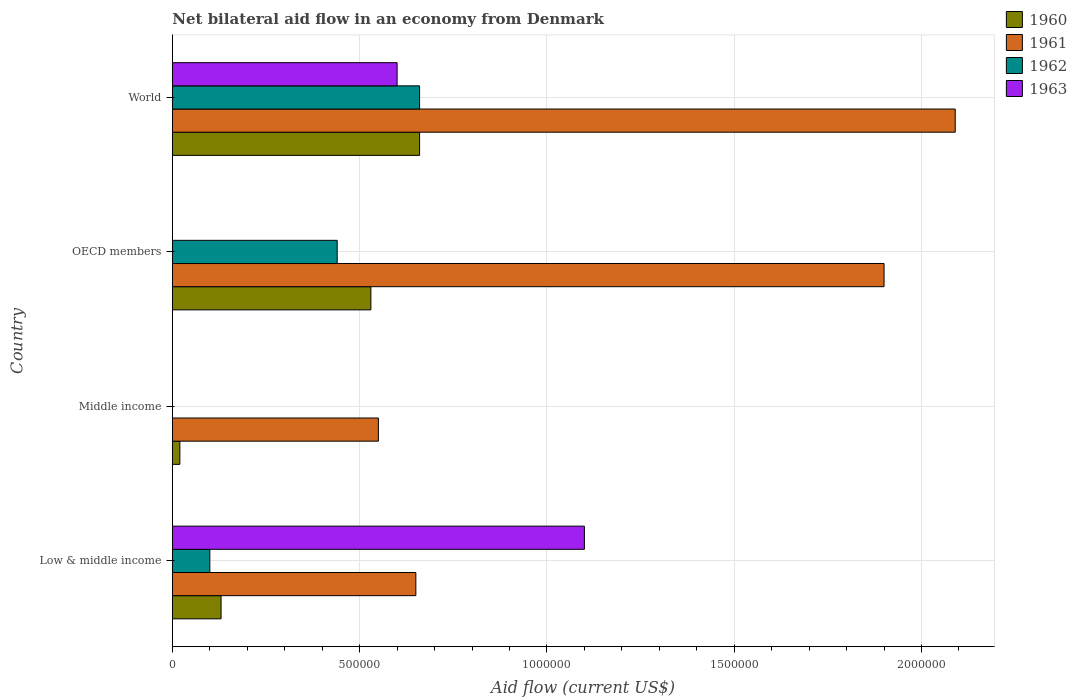How many different coloured bars are there?
Your answer should be very brief. 4. What is the label of the 3rd group of bars from the top?
Provide a short and direct response. Middle income. Across all countries, what is the maximum net bilateral aid flow in 1961?
Provide a short and direct response. 2.09e+06. What is the total net bilateral aid flow in 1960 in the graph?
Your answer should be compact. 1.34e+06. What is the difference between the net bilateral aid flow in 1961 in Middle income and that in OECD members?
Offer a terse response. -1.35e+06. What is the difference between the net bilateral aid flow in 1963 in OECD members and the net bilateral aid flow in 1961 in Low & middle income?
Provide a succinct answer. -6.50e+05. What is the average net bilateral aid flow in 1962 per country?
Your answer should be compact. 3.00e+05. What is the difference between the net bilateral aid flow in 1961 and net bilateral aid flow in 1960 in Low & middle income?
Make the answer very short. 5.20e+05. In how many countries, is the net bilateral aid flow in 1962 greater than 2000000 US$?
Your response must be concise. 0. What is the ratio of the net bilateral aid flow in 1961 in OECD members to that in World?
Make the answer very short. 0.91. Is the net bilateral aid flow in 1961 in Middle income less than that in OECD members?
Give a very brief answer. Yes. Is the difference between the net bilateral aid flow in 1961 in Middle income and World greater than the difference between the net bilateral aid flow in 1960 in Middle income and World?
Offer a very short reply. No. What is the difference between the highest and the second highest net bilateral aid flow in 1961?
Your answer should be very brief. 1.90e+05. What is the difference between the highest and the lowest net bilateral aid flow in 1963?
Give a very brief answer. 1.10e+06. Is the sum of the net bilateral aid flow in 1961 in Middle income and World greater than the maximum net bilateral aid flow in 1963 across all countries?
Offer a very short reply. Yes. Is it the case that in every country, the sum of the net bilateral aid flow in 1962 and net bilateral aid flow in 1960 is greater than the sum of net bilateral aid flow in 1963 and net bilateral aid flow in 1961?
Keep it short and to the point. No. Are all the bars in the graph horizontal?
Keep it short and to the point. Yes. Does the graph contain grids?
Your answer should be compact. Yes. Where does the legend appear in the graph?
Ensure brevity in your answer.  Top right. How are the legend labels stacked?
Offer a very short reply. Vertical. What is the title of the graph?
Your answer should be compact. Net bilateral aid flow in an economy from Denmark. What is the Aid flow (current US$) in 1961 in Low & middle income?
Your answer should be very brief. 6.50e+05. What is the Aid flow (current US$) of 1962 in Low & middle income?
Keep it short and to the point. 1.00e+05. What is the Aid flow (current US$) in 1963 in Low & middle income?
Give a very brief answer. 1.10e+06. What is the Aid flow (current US$) in 1960 in Middle income?
Your answer should be compact. 2.00e+04. What is the Aid flow (current US$) in 1961 in Middle income?
Your answer should be very brief. 5.50e+05. What is the Aid flow (current US$) of 1962 in Middle income?
Ensure brevity in your answer.  0. What is the Aid flow (current US$) in 1960 in OECD members?
Offer a terse response. 5.30e+05. What is the Aid flow (current US$) of 1961 in OECD members?
Offer a terse response. 1.90e+06. What is the Aid flow (current US$) in 1960 in World?
Provide a short and direct response. 6.60e+05. What is the Aid flow (current US$) in 1961 in World?
Keep it short and to the point. 2.09e+06. What is the Aid flow (current US$) in 1962 in World?
Your answer should be very brief. 6.60e+05. What is the Aid flow (current US$) of 1963 in World?
Your answer should be compact. 6.00e+05. Across all countries, what is the maximum Aid flow (current US$) of 1960?
Offer a very short reply. 6.60e+05. Across all countries, what is the maximum Aid flow (current US$) of 1961?
Offer a very short reply. 2.09e+06. Across all countries, what is the maximum Aid flow (current US$) of 1962?
Your answer should be compact. 6.60e+05. Across all countries, what is the maximum Aid flow (current US$) in 1963?
Offer a very short reply. 1.10e+06. Across all countries, what is the minimum Aid flow (current US$) in 1960?
Offer a very short reply. 2.00e+04. Across all countries, what is the minimum Aid flow (current US$) in 1962?
Keep it short and to the point. 0. Across all countries, what is the minimum Aid flow (current US$) in 1963?
Provide a succinct answer. 0. What is the total Aid flow (current US$) of 1960 in the graph?
Make the answer very short. 1.34e+06. What is the total Aid flow (current US$) of 1961 in the graph?
Your response must be concise. 5.19e+06. What is the total Aid flow (current US$) of 1962 in the graph?
Keep it short and to the point. 1.20e+06. What is the total Aid flow (current US$) of 1963 in the graph?
Provide a succinct answer. 1.70e+06. What is the difference between the Aid flow (current US$) of 1960 in Low & middle income and that in Middle income?
Keep it short and to the point. 1.10e+05. What is the difference between the Aid flow (current US$) of 1961 in Low & middle income and that in Middle income?
Keep it short and to the point. 1.00e+05. What is the difference between the Aid flow (current US$) of 1960 in Low & middle income and that in OECD members?
Keep it short and to the point. -4.00e+05. What is the difference between the Aid flow (current US$) of 1961 in Low & middle income and that in OECD members?
Keep it short and to the point. -1.25e+06. What is the difference between the Aid flow (current US$) in 1960 in Low & middle income and that in World?
Make the answer very short. -5.30e+05. What is the difference between the Aid flow (current US$) of 1961 in Low & middle income and that in World?
Offer a terse response. -1.44e+06. What is the difference between the Aid flow (current US$) in 1962 in Low & middle income and that in World?
Provide a short and direct response. -5.60e+05. What is the difference between the Aid flow (current US$) in 1960 in Middle income and that in OECD members?
Your response must be concise. -5.10e+05. What is the difference between the Aid flow (current US$) in 1961 in Middle income and that in OECD members?
Your answer should be very brief. -1.35e+06. What is the difference between the Aid flow (current US$) in 1960 in Middle income and that in World?
Your answer should be very brief. -6.40e+05. What is the difference between the Aid flow (current US$) in 1961 in Middle income and that in World?
Provide a succinct answer. -1.54e+06. What is the difference between the Aid flow (current US$) in 1960 in Low & middle income and the Aid flow (current US$) in 1961 in Middle income?
Make the answer very short. -4.20e+05. What is the difference between the Aid flow (current US$) of 1960 in Low & middle income and the Aid flow (current US$) of 1961 in OECD members?
Provide a succinct answer. -1.77e+06. What is the difference between the Aid flow (current US$) of 1960 in Low & middle income and the Aid flow (current US$) of 1962 in OECD members?
Make the answer very short. -3.10e+05. What is the difference between the Aid flow (current US$) in 1960 in Low & middle income and the Aid flow (current US$) in 1961 in World?
Your answer should be compact. -1.96e+06. What is the difference between the Aid flow (current US$) in 1960 in Low & middle income and the Aid flow (current US$) in 1962 in World?
Your response must be concise. -5.30e+05. What is the difference between the Aid flow (current US$) of 1960 in Low & middle income and the Aid flow (current US$) of 1963 in World?
Your answer should be very brief. -4.70e+05. What is the difference between the Aid flow (current US$) in 1961 in Low & middle income and the Aid flow (current US$) in 1963 in World?
Your response must be concise. 5.00e+04. What is the difference between the Aid flow (current US$) in 1962 in Low & middle income and the Aid flow (current US$) in 1963 in World?
Offer a terse response. -5.00e+05. What is the difference between the Aid flow (current US$) of 1960 in Middle income and the Aid flow (current US$) of 1961 in OECD members?
Provide a short and direct response. -1.88e+06. What is the difference between the Aid flow (current US$) of 1960 in Middle income and the Aid flow (current US$) of 1962 in OECD members?
Make the answer very short. -4.20e+05. What is the difference between the Aid flow (current US$) of 1961 in Middle income and the Aid flow (current US$) of 1962 in OECD members?
Your response must be concise. 1.10e+05. What is the difference between the Aid flow (current US$) of 1960 in Middle income and the Aid flow (current US$) of 1961 in World?
Your answer should be very brief. -2.07e+06. What is the difference between the Aid flow (current US$) of 1960 in Middle income and the Aid flow (current US$) of 1962 in World?
Your response must be concise. -6.40e+05. What is the difference between the Aid flow (current US$) of 1960 in Middle income and the Aid flow (current US$) of 1963 in World?
Keep it short and to the point. -5.80e+05. What is the difference between the Aid flow (current US$) of 1961 in Middle income and the Aid flow (current US$) of 1962 in World?
Provide a short and direct response. -1.10e+05. What is the difference between the Aid flow (current US$) of 1960 in OECD members and the Aid flow (current US$) of 1961 in World?
Keep it short and to the point. -1.56e+06. What is the difference between the Aid flow (current US$) in 1960 in OECD members and the Aid flow (current US$) in 1963 in World?
Provide a short and direct response. -7.00e+04. What is the difference between the Aid flow (current US$) of 1961 in OECD members and the Aid flow (current US$) of 1962 in World?
Your answer should be compact. 1.24e+06. What is the difference between the Aid flow (current US$) of 1961 in OECD members and the Aid flow (current US$) of 1963 in World?
Give a very brief answer. 1.30e+06. What is the difference between the Aid flow (current US$) in 1962 in OECD members and the Aid flow (current US$) in 1963 in World?
Your answer should be very brief. -1.60e+05. What is the average Aid flow (current US$) of 1960 per country?
Your response must be concise. 3.35e+05. What is the average Aid flow (current US$) in 1961 per country?
Offer a very short reply. 1.30e+06. What is the average Aid flow (current US$) of 1962 per country?
Provide a short and direct response. 3.00e+05. What is the average Aid flow (current US$) in 1963 per country?
Your answer should be very brief. 4.25e+05. What is the difference between the Aid flow (current US$) in 1960 and Aid flow (current US$) in 1961 in Low & middle income?
Provide a succinct answer. -5.20e+05. What is the difference between the Aid flow (current US$) of 1960 and Aid flow (current US$) of 1963 in Low & middle income?
Ensure brevity in your answer.  -9.70e+05. What is the difference between the Aid flow (current US$) in 1961 and Aid flow (current US$) in 1963 in Low & middle income?
Your answer should be compact. -4.50e+05. What is the difference between the Aid flow (current US$) in 1960 and Aid flow (current US$) in 1961 in Middle income?
Offer a very short reply. -5.30e+05. What is the difference between the Aid flow (current US$) of 1960 and Aid flow (current US$) of 1961 in OECD members?
Provide a short and direct response. -1.37e+06. What is the difference between the Aid flow (current US$) in 1961 and Aid flow (current US$) in 1962 in OECD members?
Provide a short and direct response. 1.46e+06. What is the difference between the Aid flow (current US$) of 1960 and Aid flow (current US$) of 1961 in World?
Provide a short and direct response. -1.43e+06. What is the difference between the Aid flow (current US$) of 1961 and Aid flow (current US$) of 1962 in World?
Your response must be concise. 1.43e+06. What is the difference between the Aid flow (current US$) of 1961 and Aid flow (current US$) of 1963 in World?
Your answer should be very brief. 1.49e+06. What is the difference between the Aid flow (current US$) of 1962 and Aid flow (current US$) of 1963 in World?
Provide a succinct answer. 6.00e+04. What is the ratio of the Aid flow (current US$) in 1961 in Low & middle income to that in Middle income?
Provide a succinct answer. 1.18. What is the ratio of the Aid flow (current US$) in 1960 in Low & middle income to that in OECD members?
Ensure brevity in your answer.  0.25. What is the ratio of the Aid flow (current US$) of 1961 in Low & middle income to that in OECD members?
Your answer should be very brief. 0.34. What is the ratio of the Aid flow (current US$) in 1962 in Low & middle income to that in OECD members?
Make the answer very short. 0.23. What is the ratio of the Aid flow (current US$) in 1960 in Low & middle income to that in World?
Your response must be concise. 0.2. What is the ratio of the Aid flow (current US$) of 1961 in Low & middle income to that in World?
Your response must be concise. 0.31. What is the ratio of the Aid flow (current US$) of 1962 in Low & middle income to that in World?
Give a very brief answer. 0.15. What is the ratio of the Aid flow (current US$) of 1963 in Low & middle income to that in World?
Offer a very short reply. 1.83. What is the ratio of the Aid flow (current US$) of 1960 in Middle income to that in OECD members?
Give a very brief answer. 0.04. What is the ratio of the Aid flow (current US$) of 1961 in Middle income to that in OECD members?
Keep it short and to the point. 0.29. What is the ratio of the Aid flow (current US$) in 1960 in Middle income to that in World?
Your response must be concise. 0.03. What is the ratio of the Aid flow (current US$) in 1961 in Middle income to that in World?
Ensure brevity in your answer.  0.26. What is the ratio of the Aid flow (current US$) in 1960 in OECD members to that in World?
Your answer should be very brief. 0.8. What is the ratio of the Aid flow (current US$) of 1961 in OECD members to that in World?
Provide a short and direct response. 0.91. What is the difference between the highest and the second highest Aid flow (current US$) in 1960?
Give a very brief answer. 1.30e+05. What is the difference between the highest and the lowest Aid flow (current US$) of 1960?
Give a very brief answer. 6.40e+05. What is the difference between the highest and the lowest Aid flow (current US$) of 1961?
Your answer should be compact. 1.54e+06. What is the difference between the highest and the lowest Aid flow (current US$) of 1963?
Your answer should be compact. 1.10e+06. 